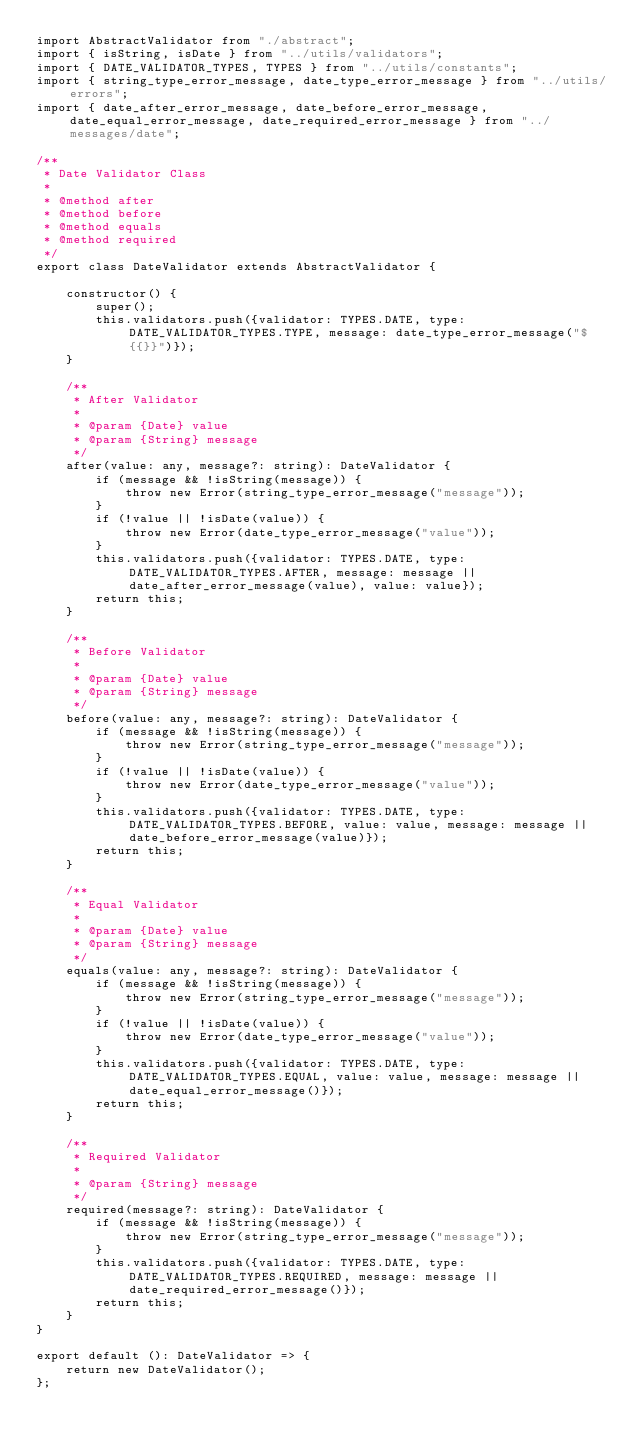Convert code to text. <code><loc_0><loc_0><loc_500><loc_500><_TypeScript_>import AbstractValidator from "./abstract";
import { isString, isDate } from "../utils/validators";
import { DATE_VALIDATOR_TYPES, TYPES } from "../utils/constants";
import { string_type_error_message, date_type_error_message } from "../utils/errors";
import { date_after_error_message, date_before_error_message, date_equal_error_message, date_required_error_message } from "../messages/date";

/**
 * Date Validator Class
 * 
 * @method after
 * @method before
 * @method equals
 * @method required
 */
export class DateValidator extends AbstractValidator {

    constructor() {
        super();
        this.validators.push({validator: TYPES.DATE, type: DATE_VALIDATOR_TYPES.TYPE, message: date_type_error_message("${{}}")});
    }

    /**
     * After Validator
     * 
     * @param {Date} value 
     * @param {String} message 
     */
    after(value: any, message?: string): DateValidator {
        if (message && !isString(message)) {
            throw new Error(string_type_error_message("message"));
        }
        if (!value || !isDate(value)) {
            throw new Error(date_type_error_message("value"));
        }
        this.validators.push({validator: TYPES.DATE, type: DATE_VALIDATOR_TYPES.AFTER, message: message || date_after_error_message(value), value: value});
        return this;
    }

    /**
     * Before Validator
     * 
     * @param {Date} value 
     * @param {String} message 
     */
    before(value: any, message?: string): DateValidator {
        if (message && !isString(message)) {
            throw new Error(string_type_error_message("message"));
        }
        if (!value || !isDate(value)) {
            throw new Error(date_type_error_message("value"));
        }
        this.validators.push({validator: TYPES.DATE, type: DATE_VALIDATOR_TYPES.BEFORE, value: value, message: message || date_before_error_message(value)});
        return this;
    }

    /**
     * Equal Validator
     * 
     * @param {Date} value 
     * @param {String} message 
     */
    equals(value: any, message?: string): DateValidator {
        if (message && !isString(message)) {
            throw new Error(string_type_error_message("message"));
        }
        if (!value || !isDate(value)) {
            throw new Error(date_type_error_message("value"));
        }
        this.validators.push({validator: TYPES.DATE, type: DATE_VALIDATOR_TYPES.EQUAL, value: value, message: message || date_equal_error_message()});
        return this;
    }

    /**
     * Required Validator
     * 
     * @param {String} message 
     */
    required(message?: string): DateValidator {
        if (message && !isString(message)) {
            throw new Error(string_type_error_message("message"));
        }
        this.validators.push({validator: TYPES.DATE, type: DATE_VALIDATOR_TYPES.REQUIRED, message: message || date_required_error_message()});
        return this;
    }
}

export default (): DateValidator => {
    return new DateValidator();
};

</code> 